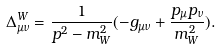<formula> <loc_0><loc_0><loc_500><loc_500>\Delta _ { \mu \nu } ^ { W } = \frac { 1 } { p ^ { 2 } - m _ { W } ^ { 2 } } ( - g _ { \mu \nu } + \frac { p _ { \mu } p _ { \nu } } { m _ { W } ^ { 2 } } ) .</formula> 